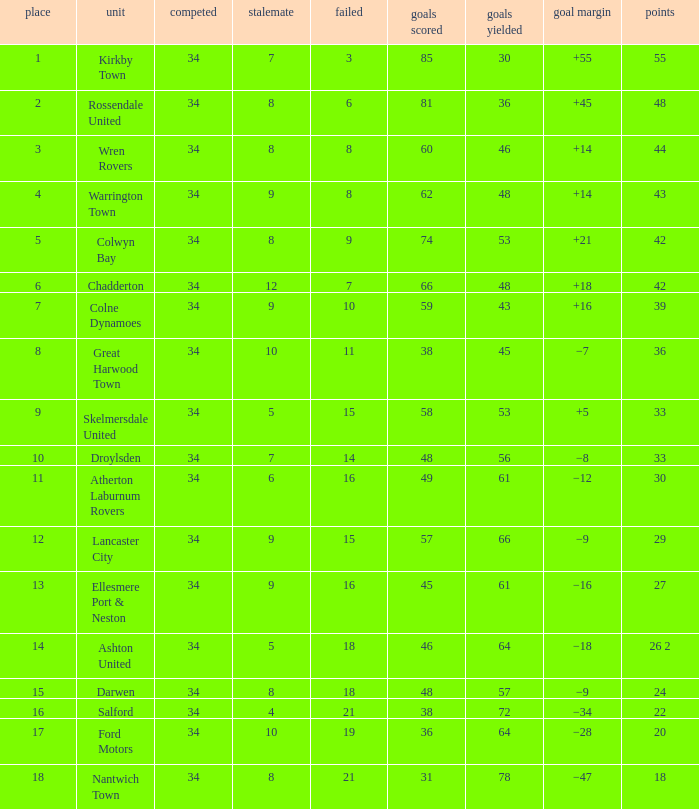What is the smallest number of goals against when 8 games were lost, and the goals for are 60? 46.0. 